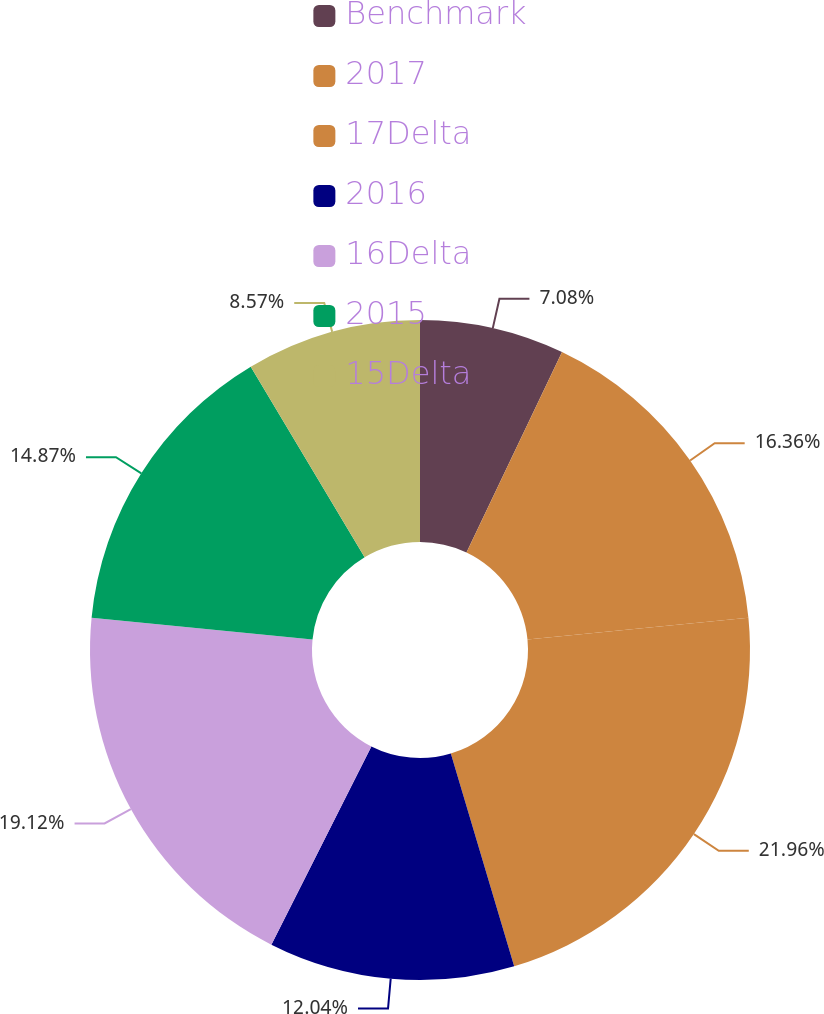Convert chart to OTSL. <chart><loc_0><loc_0><loc_500><loc_500><pie_chart><fcel>Benchmark<fcel>2017<fcel>17Delta<fcel>2016<fcel>16Delta<fcel>2015<fcel>15Delta<nl><fcel>7.08%<fcel>16.36%<fcel>21.95%<fcel>12.04%<fcel>19.12%<fcel>14.87%<fcel>8.57%<nl></chart> 